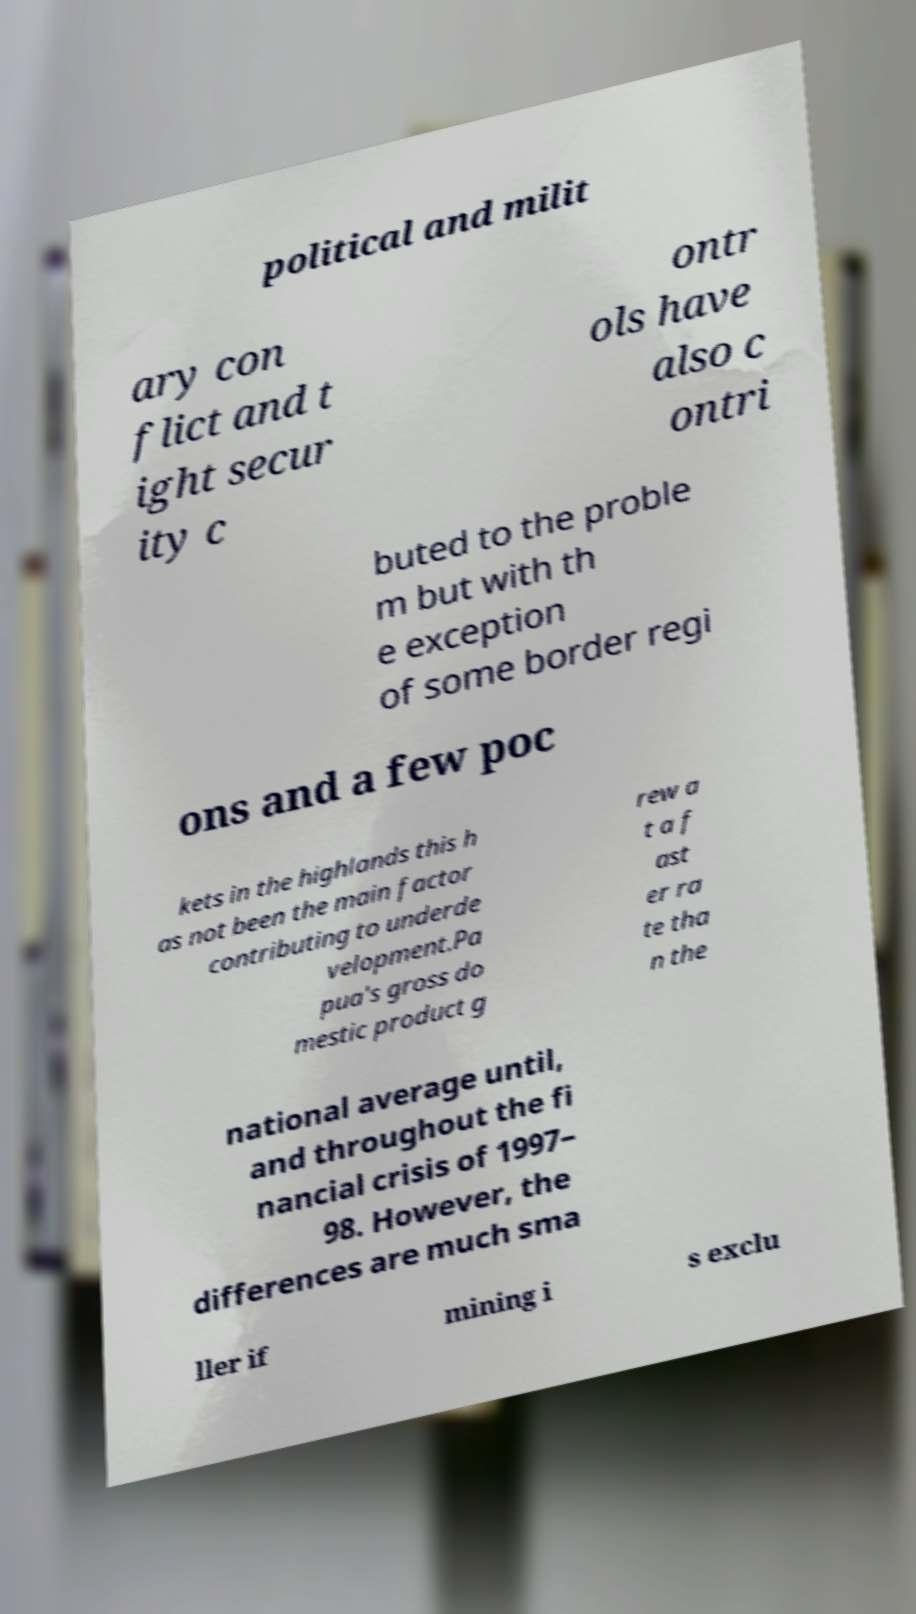Could you extract and type out the text from this image? political and milit ary con flict and t ight secur ity c ontr ols have also c ontri buted to the proble m but with th e exception of some border regi ons and a few poc kets in the highlands this h as not been the main factor contributing to underde velopment.Pa pua's gross do mestic product g rew a t a f ast er ra te tha n the national average until, and throughout the fi nancial crisis of 1997– 98. However, the differences are much sma ller if mining i s exclu 